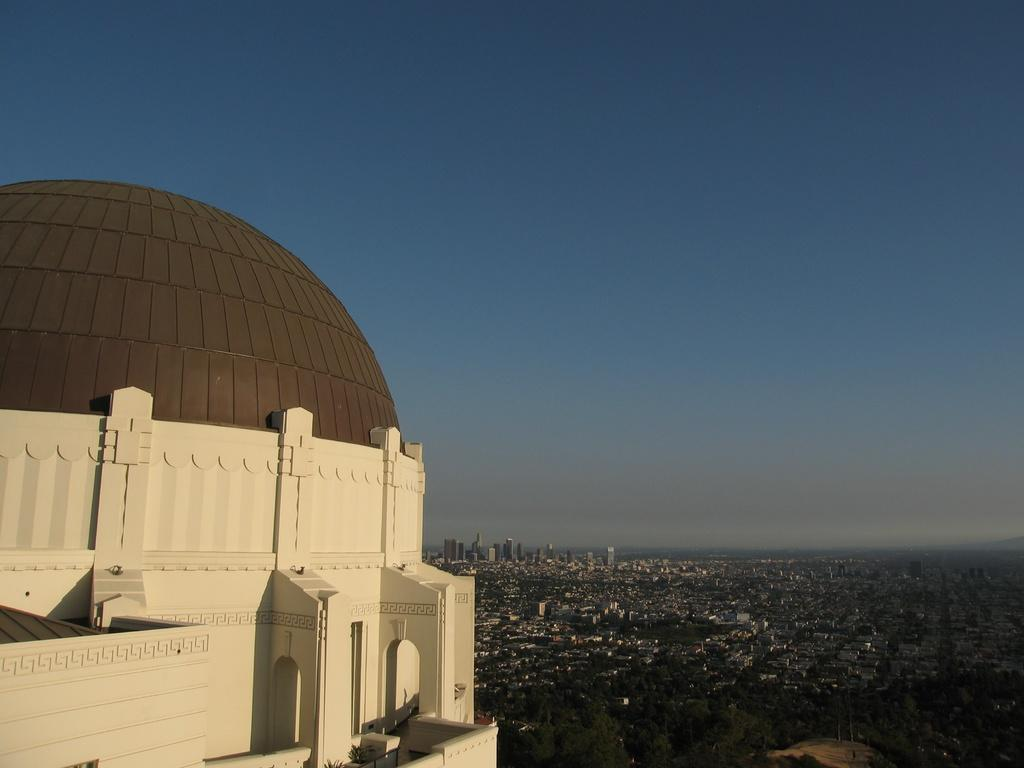What structure is located on the left side of the image? There is a building on the left side of the image. What is visible at the top of the image? The sky is visible at the top of the image. Are there any giants visible in the image? No, there are no giants present in the image. What type of exchange is taking place in the image? There is no exchange taking place in the image; it only features a building and the sky. 